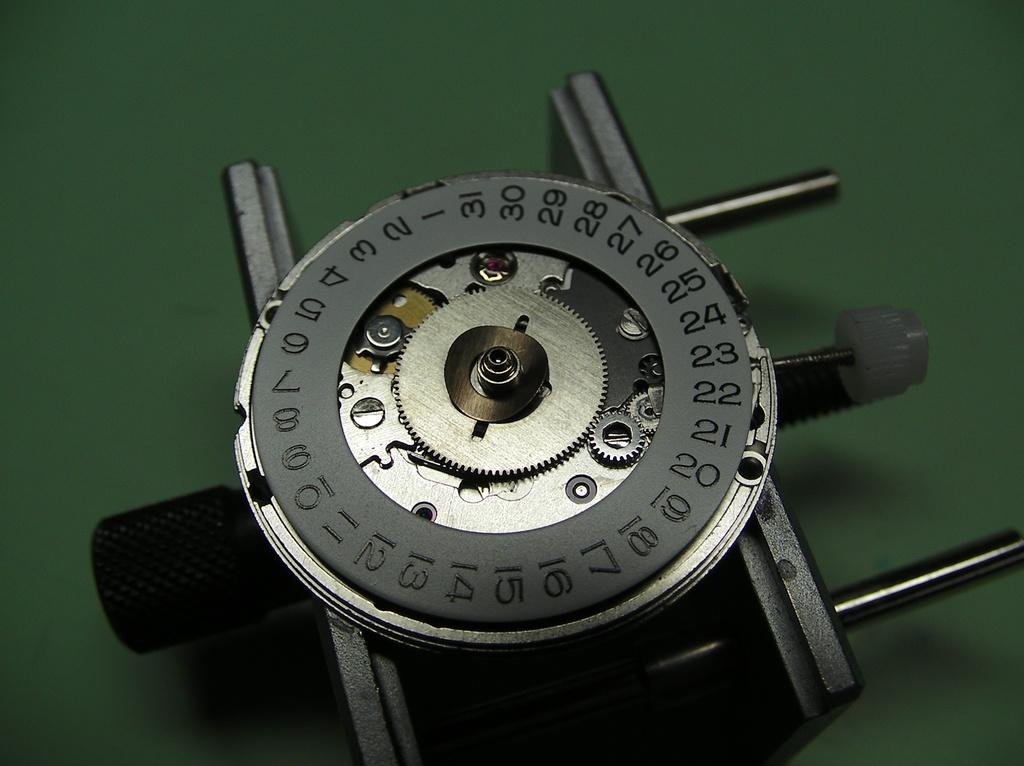<image>
Write a terse but informative summary of the picture. Some sort of device that is grey and silver and has numbers printed along the edges. 